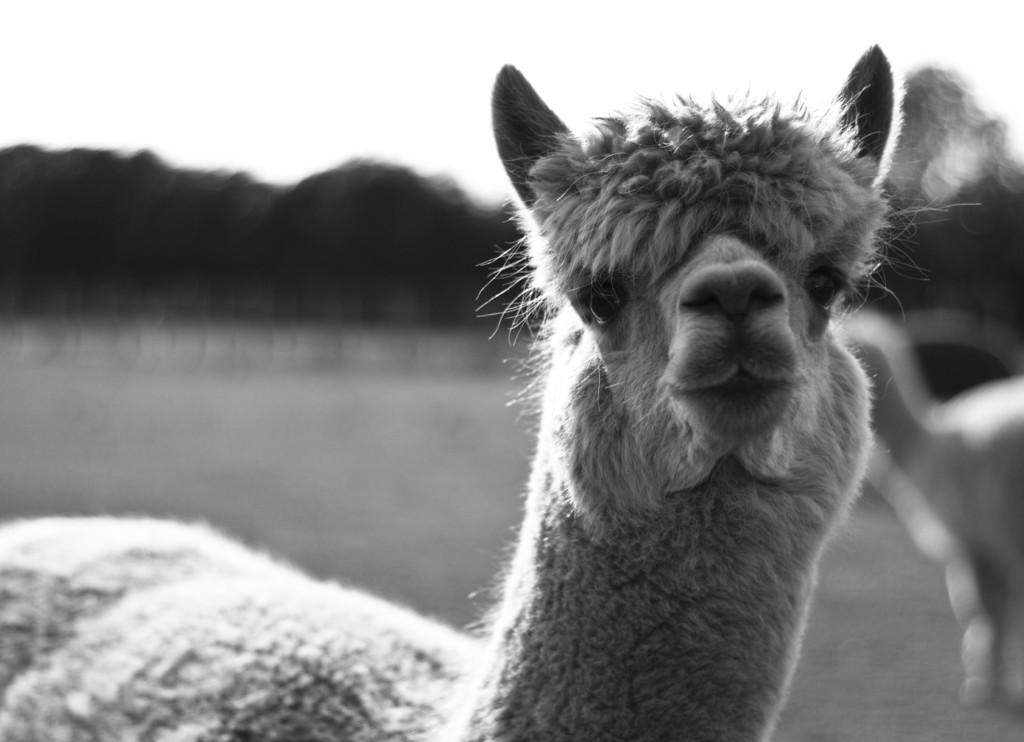What is the color scheme of the image? The image is black and white. What type of subject can be seen in the image? There is an animal in the image. Can you describe the background of the image? The background of the image is blurred. Where is the aunt taking a bath in the image? There is no aunt or bath present in the image; it features a black and white image of an animal with a blurred background. 